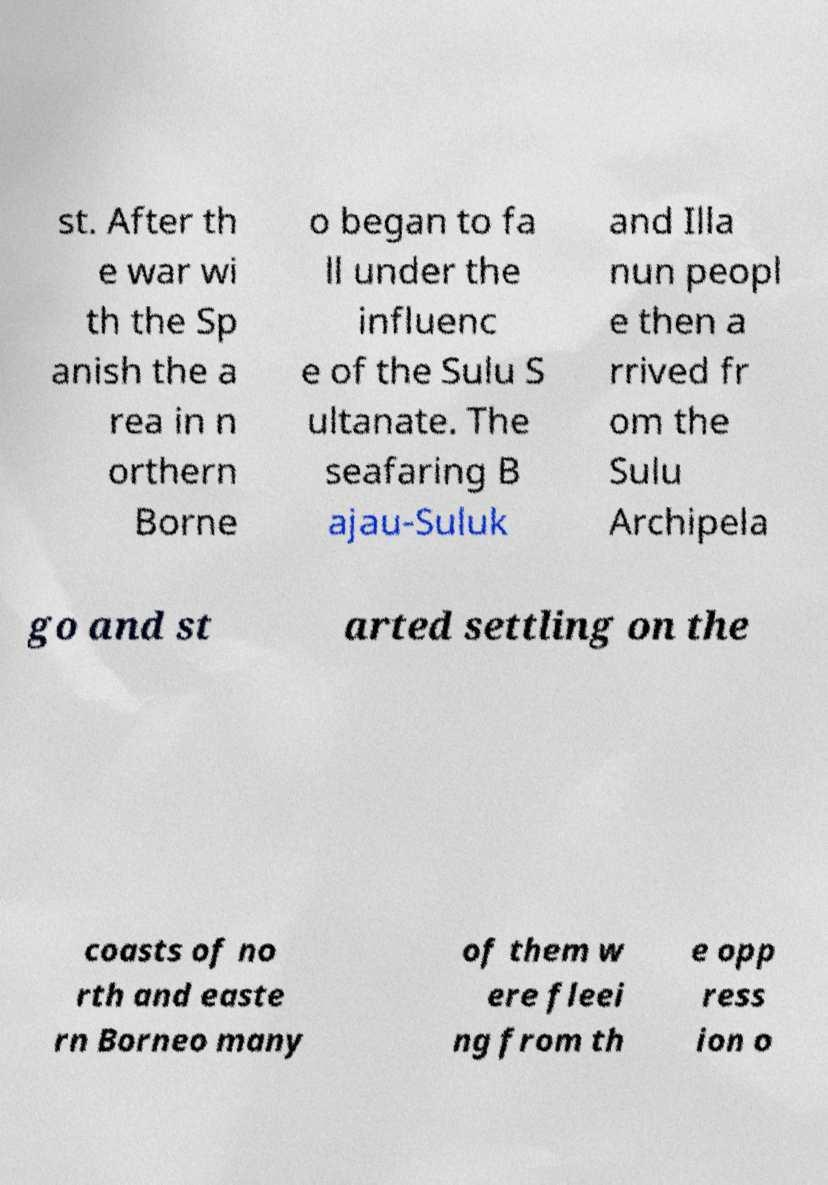Could you extract and type out the text from this image? st. After th e war wi th the Sp anish the a rea in n orthern Borne o began to fa ll under the influenc e of the Sulu S ultanate. The seafaring B ajau-Suluk and Illa nun peopl e then a rrived fr om the Sulu Archipela go and st arted settling on the coasts of no rth and easte rn Borneo many of them w ere fleei ng from th e opp ress ion o 